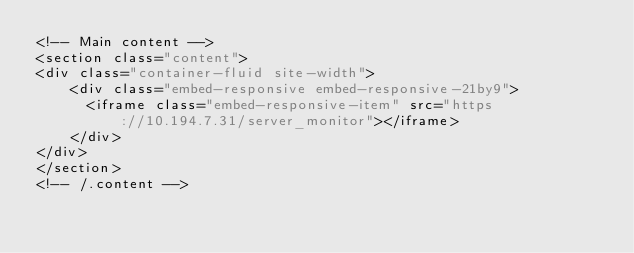Convert code to text. <code><loc_0><loc_0><loc_500><loc_500><_PHP_><!-- Main content -->
<section class="content">
<div class="container-fluid site-width">
	<div class="embed-responsive embed-responsive-21by9">
	  <iframe class="embed-responsive-item" src="https://10.194.7.31/server_monitor"></iframe>
	</div>
</div>
</section>
<!-- /.content -->

  </code> 